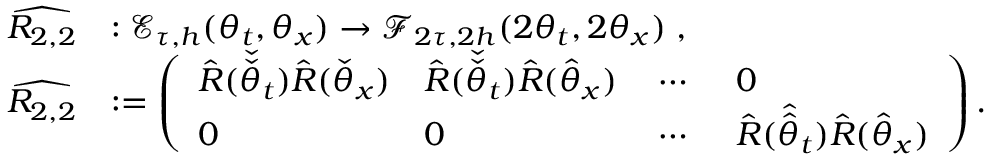Convert formula to latex. <formula><loc_0><loc_0><loc_500><loc_500>\begin{array} { r l } { \widehat { R _ { 2 , 2 } } } & { \colon \mathcal { E } _ { \tau , h } ( \theta _ { t } , \theta _ { x } ) \to \mathcal { F } _ { 2 \tau , 2 h } ( 2 \theta _ { t } , 2 \theta _ { x } ) \, , } \\ { \widehat { R _ { 2 , 2 } } } & { \colon = \left ( \begin{array} { l l l l } { \hat { R } ( \check { \check { \theta } } _ { t } ) \hat { R } ( \check { \theta } _ { x } ) } & { \hat { R } ( \check { \check { \theta } } _ { t } ) \hat { R } ( \hat { \theta } _ { x } ) } & { \, \cdots \, } & { 0 } \\ { 0 } & { 0 } & { \, \cdots \, } & { \hat { R } ( \hat { \hat { \theta } } _ { t } ) \hat { R } ( \hat { \theta } _ { x } ) } \end{array} \right ) . } \end{array}</formula> 